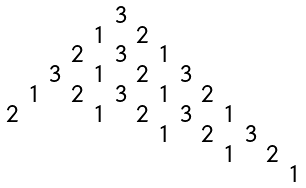Convert formula to latex. <formula><loc_0><loc_0><loc_500><loc_500>\begin{smallmatrix} & & & & & 3 \\ & & & & 1 & & 2 \\ & & & 2 & & 3 & & 1 \\ & & 3 & & 1 & & 2 & & 3 \\ & 1 & & 2 & & 3 & & 1 & & 2 \\ 2 & & & & 1 & & 2 & & 3 & & 1 \\ & & & & & & & 1 & & 2 & & 3 \\ & & & & & & & & & & 1 & & 2 \\ & & & & & & & & & & & & & 1 \end{smallmatrix}</formula> 